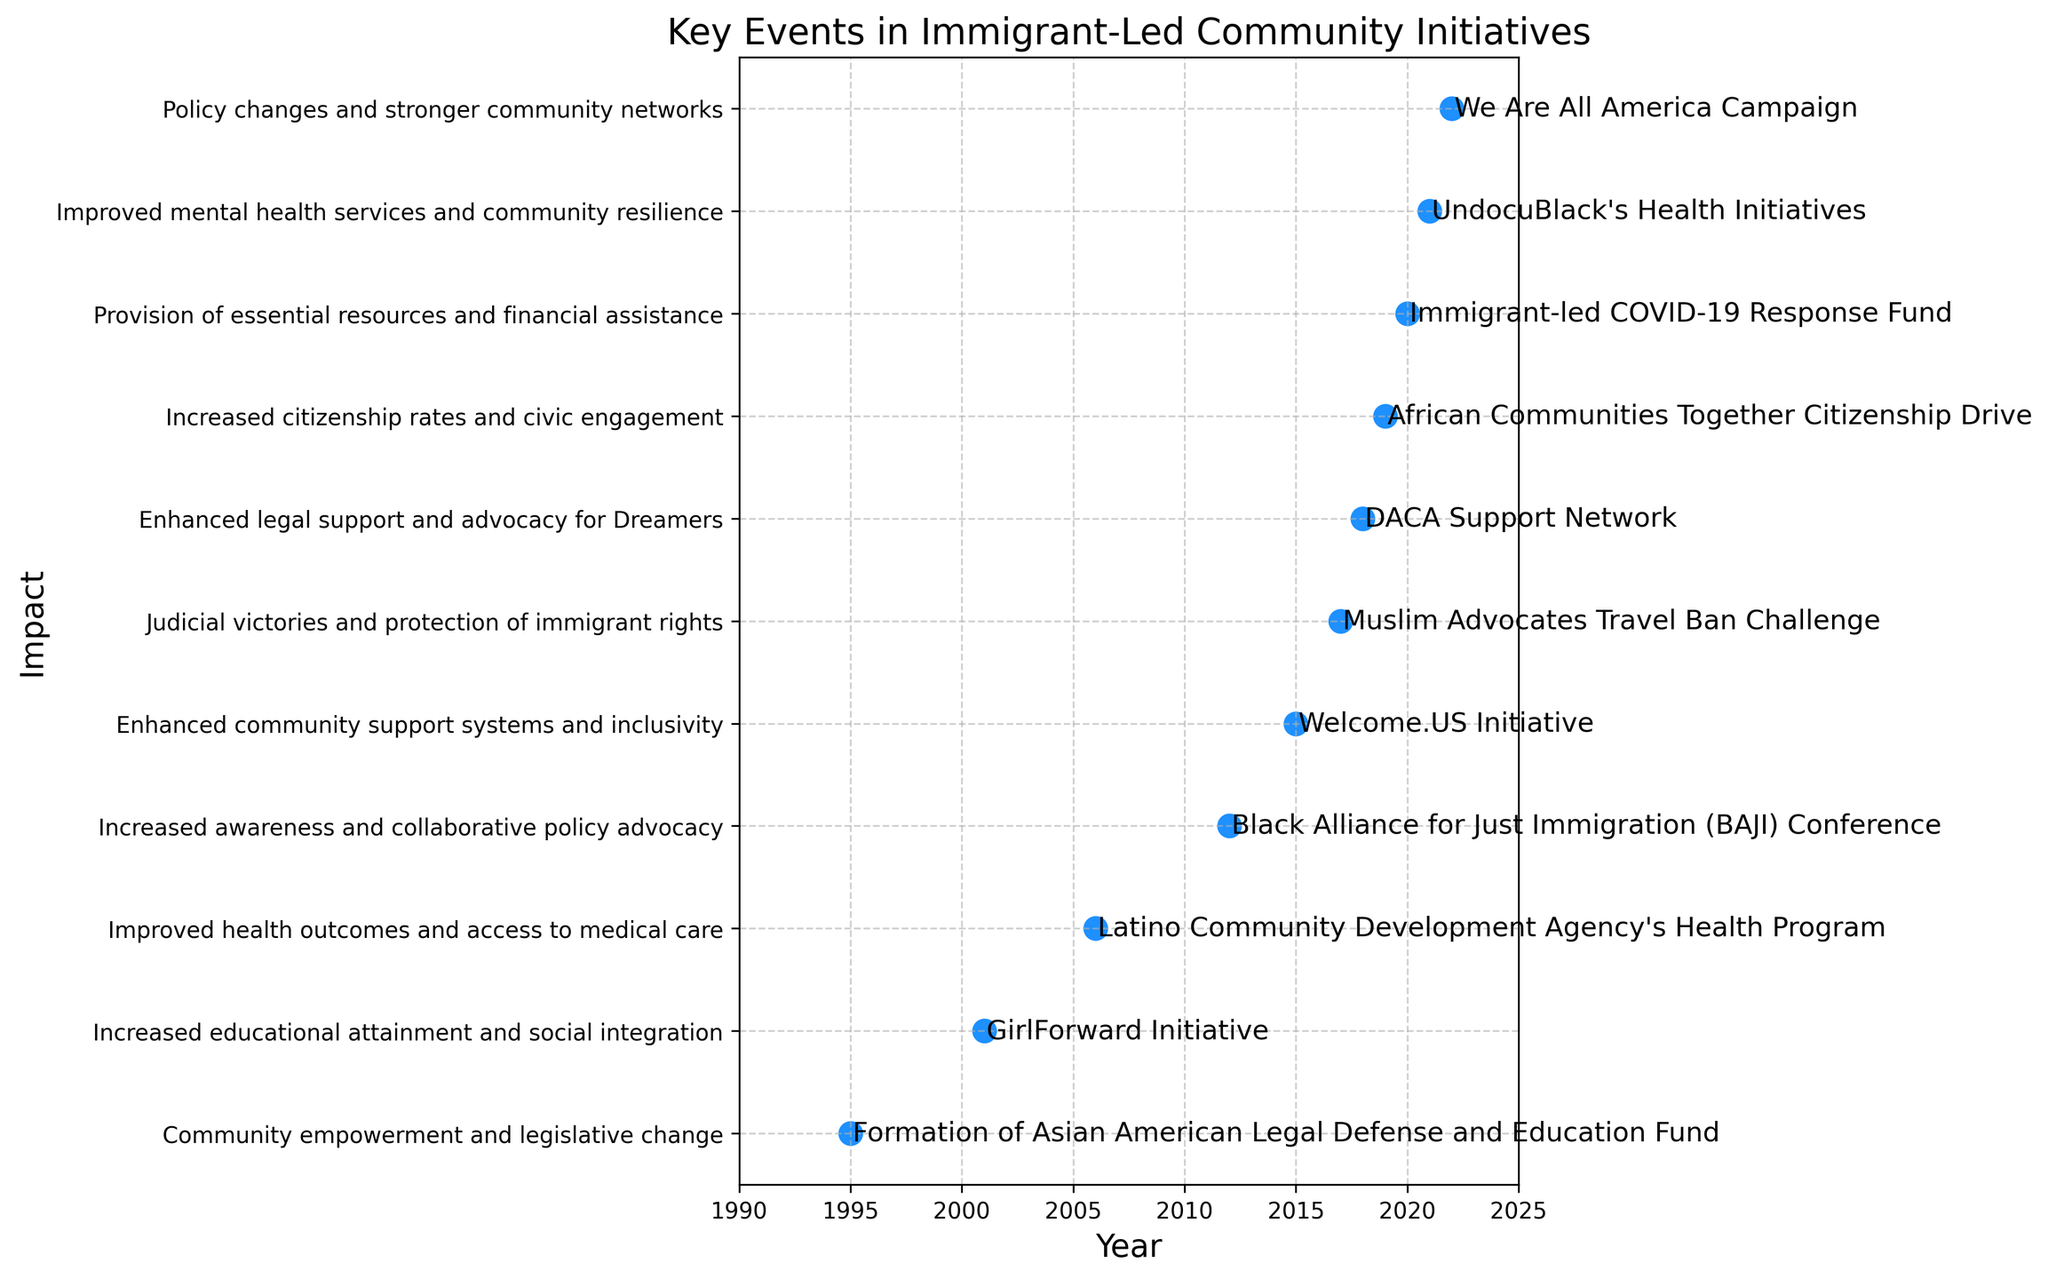Which event had the earliest occurrence as shown in the plot? The plot shows the earliest event at the leftmost point on the x-axis, which corresponds to the year. The event at the year 1995 is the earliest.
Answer: The Formation of Asian American Legal Defense and Education Fund in 1995 What is the chronological order of events from 2015 to 2019? The years 2015 to 2019 can be read along the x-axis. The events listed in order from these years are: Welcome.US Initiative (2015), Muslim Advocates Travel Ban Challenge (2017), DACA Support Network (2018), and African Communities Together Citizenship Drive (2019).
Answer: Welcome.US Initiative, Muslim Advocates Travel Ban Challenge, DACA Support Network, African Communities Together Citizenship Drive Which events are specifically aimed at supporting girls or women in immigrant communities? By examining the event descriptions, the GirlForward Initiative launched in 2001 focuses on supporting adolescent refugee girls.
Answer: GirlForward Initiative Which event in the plot resulted in improved health outcomes and access to medical care? The y-axis labels the impact, and the event associated with "Improved health outcomes and access to medical care" is the 2006 Latino Community Development Agency's Health Program.
Answer: Latino Community Development Agency's Health Program How many events occurred before the year 2010? Counting the events from the leftmost point up to and including the year 2009, we have events in 1995 (1), 2001 (2), and 2006 (3), giving a total of three events.
Answer: 3 Which event is associated with "Judicial victories and protection of immigrant rights," and when did it occur? The y-axis labels the impacts, and next to "Judicial victories and protection of immigrant rights," the event shown on the timeline is the 2017 Muslim Advocates Travel Ban Challenge.
Answer: Muslim Advocates Travel Ban Challenge in 2017 What is the impact of the "Immigrant-led COVID-19 Response Fund" event? By referring to the event name on the x-axis and finding its associated impact on the y-axis, we see that the impact is "Provision of essential resources and financial assistance."
Answer: Provision of essential resources and financial assistance How many events are linked to the impact "Enhanced community support systems and inclusivity"? Searching the y-axis labels for "Enhanced community support systems and inclusivity," we identify one event, which is the 2015 Welcome.US Initiative.
Answer: 1 Which event had an impact on the "mental health support for undocumented Black immigrants"? The y-axis labels indicate "Improved mental health services and community resilience" as the impact of the event occurring in 2021, which is UndocuBlack's Health Initiatives.
Answer: UndocuBlack's Health Initiatives in 2021 In terms of number of events, compare the period between 1995-2010 and 2011-2022. Count the number of events occurring from 1995 to 2010 (Formation of Asian American Legal Defense and Education Fund, GirlForward Initiative, Latino Community Development Agency's Health Program) which are 3 events, and then count from 2011 to 2022 (BAJI Conference, Welcome.US Initiative, Muslim Advocates Travel Ban Challenge, DACA Support Network, African Communities Together Citizenship Drive, Immigrant-led COVID-19 Response Fund, UndocuBlack's Health Initiatives, We Are All America Campaign) which are 8 events.
Answer: 3 in 1995-2010 and 8 in 2011-2022 